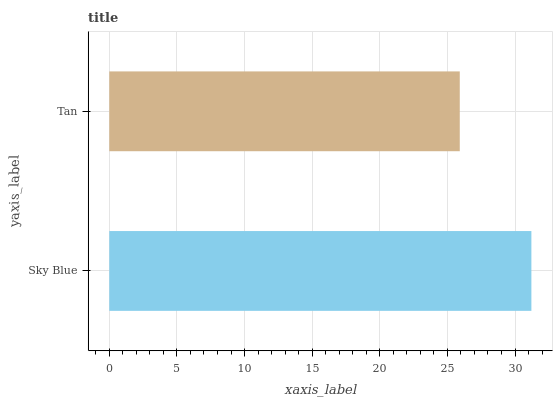Is Tan the minimum?
Answer yes or no. Yes. Is Sky Blue the maximum?
Answer yes or no. Yes. Is Tan the maximum?
Answer yes or no. No. Is Sky Blue greater than Tan?
Answer yes or no. Yes. Is Tan less than Sky Blue?
Answer yes or no. Yes. Is Tan greater than Sky Blue?
Answer yes or no. No. Is Sky Blue less than Tan?
Answer yes or no. No. Is Sky Blue the high median?
Answer yes or no. Yes. Is Tan the low median?
Answer yes or no. Yes. Is Tan the high median?
Answer yes or no. No. Is Sky Blue the low median?
Answer yes or no. No. 